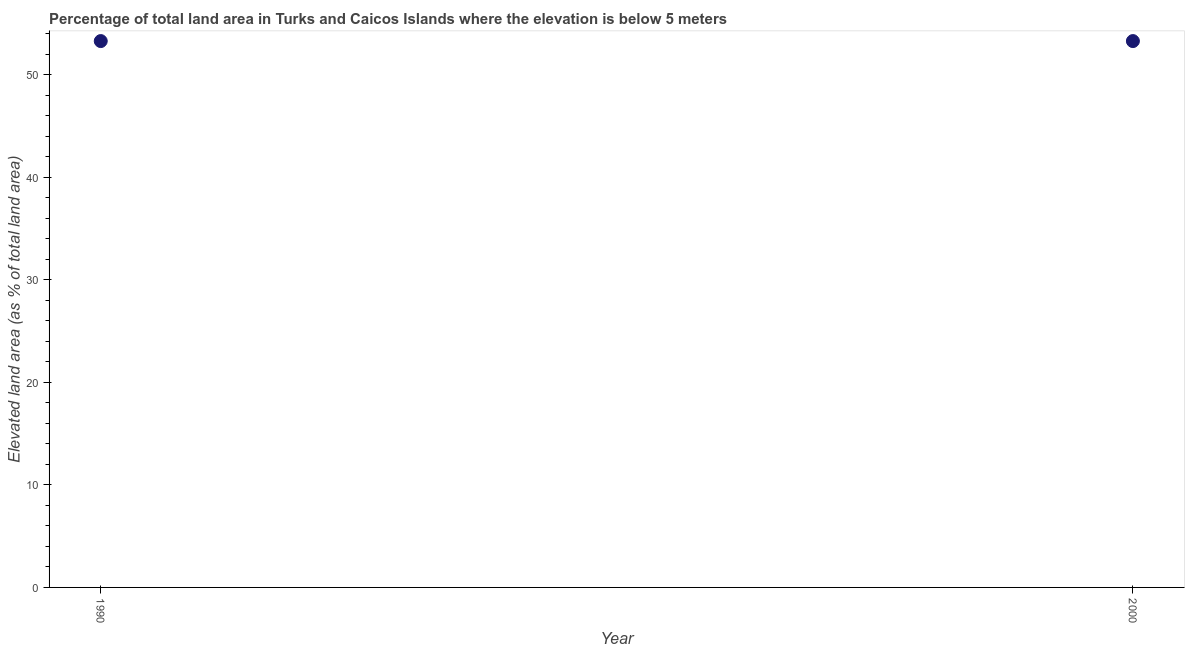What is the total elevated land area in 2000?
Offer a very short reply. 53.27. Across all years, what is the maximum total elevated land area?
Offer a very short reply. 53.27. Across all years, what is the minimum total elevated land area?
Make the answer very short. 53.27. In which year was the total elevated land area maximum?
Keep it short and to the point. 1990. In which year was the total elevated land area minimum?
Your answer should be compact. 1990. What is the sum of the total elevated land area?
Offer a terse response. 106.55. What is the difference between the total elevated land area in 1990 and 2000?
Give a very brief answer. 0. What is the average total elevated land area per year?
Provide a succinct answer. 53.27. What is the median total elevated land area?
Ensure brevity in your answer.  53.27. Do a majority of the years between 2000 and 1990 (inclusive) have total elevated land area greater than 46 %?
Make the answer very short. No. What is the ratio of the total elevated land area in 1990 to that in 2000?
Provide a succinct answer. 1. Is the total elevated land area in 1990 less than that in 2000?
Ensure brevity in your answer.  No. In how many years, is the total elevated land area greater than the average total elevated land area taken over all years?
Give a very brief answer. 0. How many dotlines are there?
Provide a succinct answer. 1. What is the difference between two consecutive major ticks on the Y-axis?
Provide a succinct answer. 10. Does the graph contain any zero values?
Provide a short and direct response. No. What is the title of the graph?
Keep it short and to the point. Percentage of total land area in Turks and Caicos Islands where the elevation is below 5 meters. What is the label or title of the Y-axis?
Make the answer very short. Elevated land area (as % of total land area). What is the Elevated land area (as % of total land area) in 1990?
Your answer should be very brief. 53.27. What is the Elevated land area (as % of total land area) in 2000?
Give a very brief answer. 53.27. What is the difference between the Elevated land area (as % of total land area) in 1990 and 2000?
Ensure brevity in your answer.  0. What is the ratio of the Elevated land area (as % of total land area) in 1990 to that in 2000?
Provide a short and direct response. 1. 